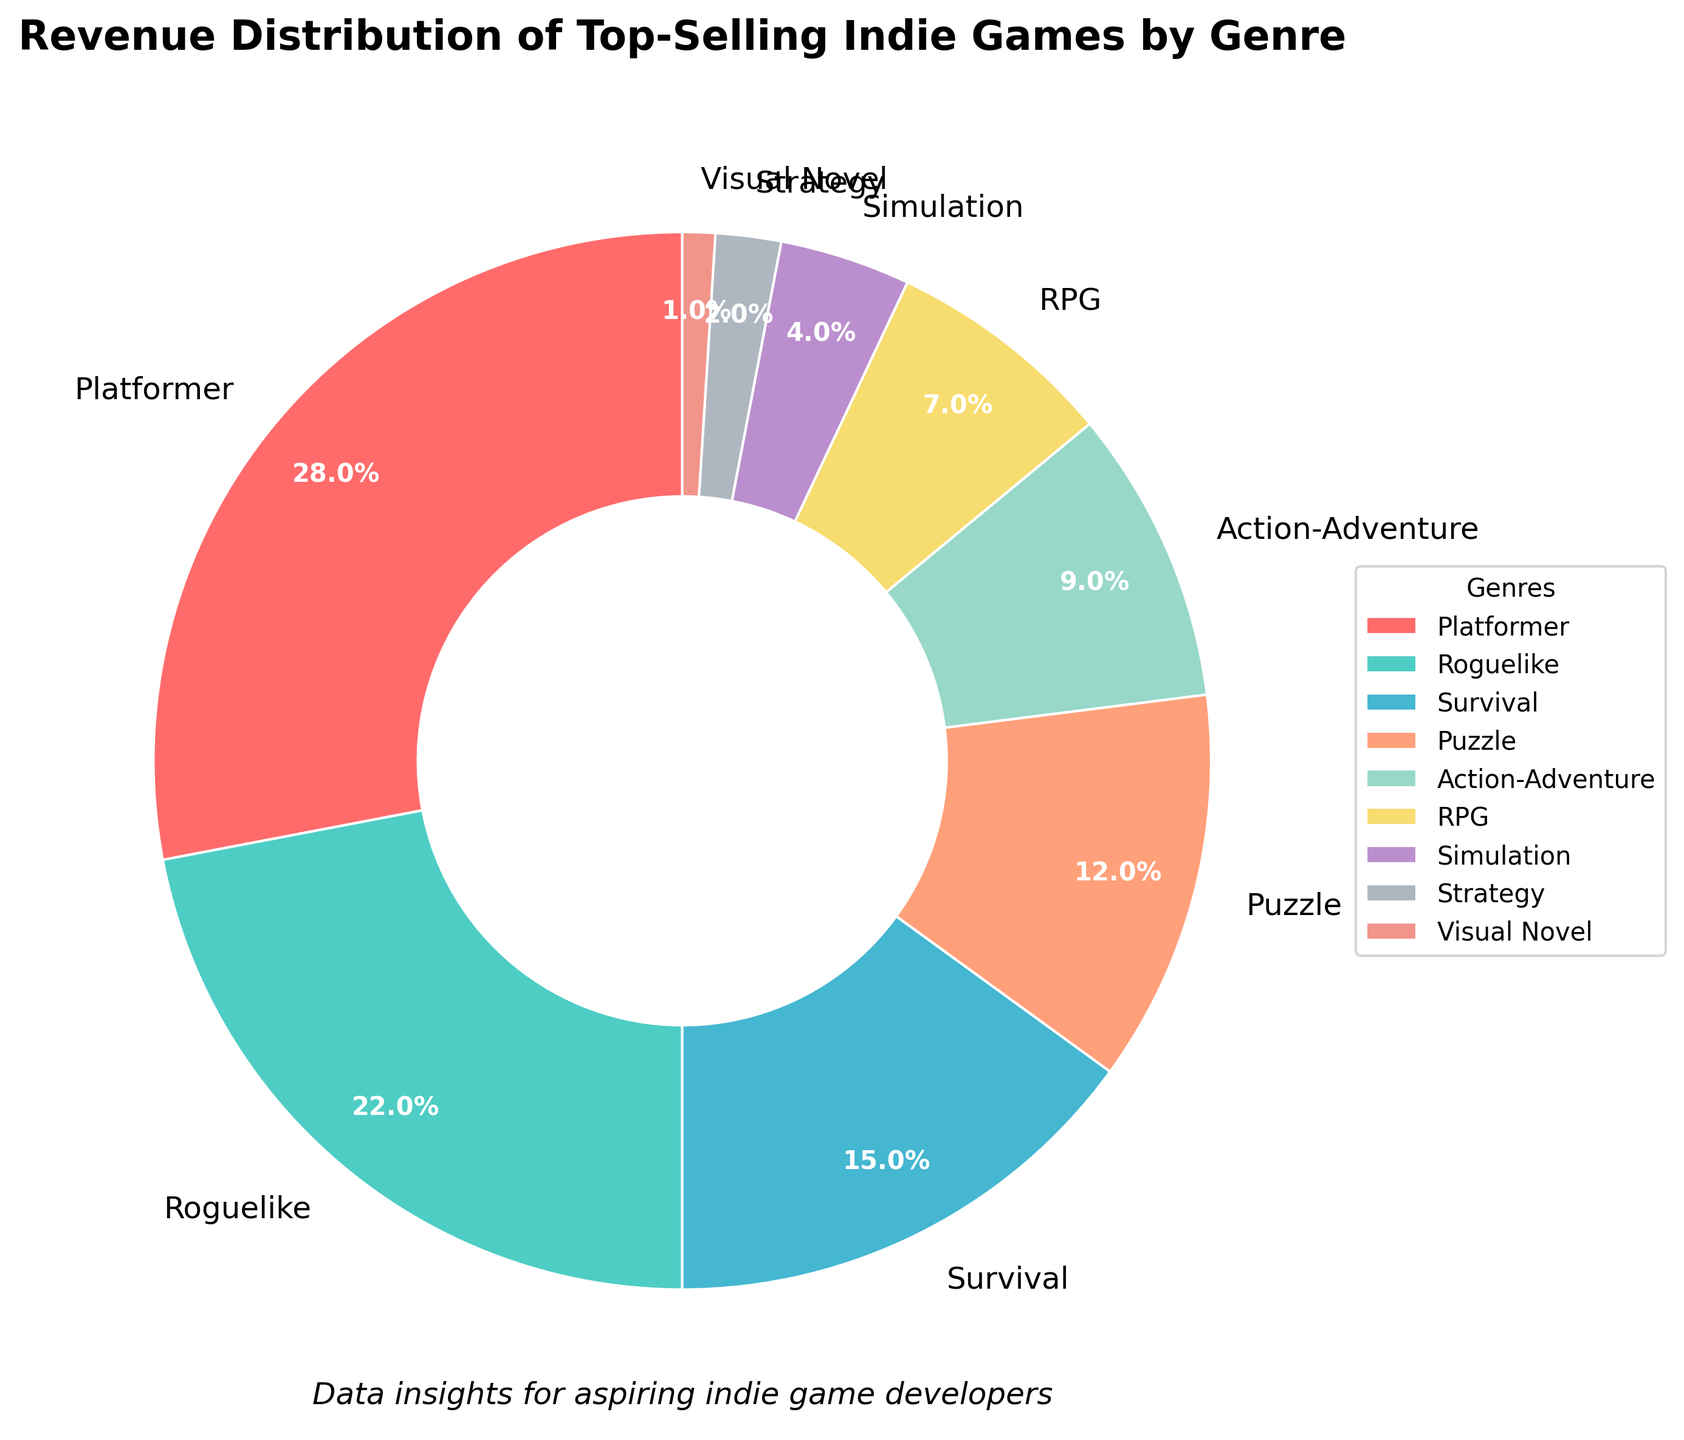Which genre contributes the highest percentage to the total revenue? The pie chart shows the revenue distribution by genre, and the largest slice represents the highest contribution. Here, "Platformer" has the biggest slice with 28%.
Answer: Platformer What is the combined revenue percentage of Roguelike and Survival genres? Sum the revenue percentages of Roguelike (22%) and Survival (15%). 22 + 15 = 37.
Answer: 37 Which genres combined contribute less than 10% each to the total revenue? Look for slices with percentages less than 10%. "Simulation," "Strategy," and "Visual Novel" have percentages of 4%, 2%, and 1%, respectively.
Answer: Simulation, Strategy, Visual Novel How much more revenue does the Platformer genre generate compared to the RPG genre? Subtract the percentage of RPG (7%) from Platformer (28%). 28 - 7 = 21.
Answer: 21 Which genre has the smallest contribution, and what is that percentage? The smallest slice shows the least contribution. "Visual Novel" has the smallest percentage at 1%.
Answer: Visual Novel, 1 What is the difference in revenue percentage between Roguelike and Action-Adventure genres? Subtract the percentage of Action-Adventure (9%) from Roguelike (22%). 22 - 9 = 13.
Answer: 13 If you combine Puzzle and RPG genres, do they surpass the revenue contribution of Survival? Add the percentages of Puzzle (12%) and RPG (7%), then compare it to Survival (15%). 12 + 7 = 19, which is greater than 15.
Answer: Yes What is the average revenue percentage of the Survival, Puzzle, and Action-Adventure genres? Sum the percentages of Survival (15%), Puzzle (12%), and Action-Adventure (9%), then divide by 3. (15 + 12 + 9) / 3 = 12.
Answer: 12 How does the revenue contribution of Simulation compare to that of Strategy? Compare the percentages directly. Simulation has 4%, and Strategy has 2%; thus, Simulation contributes more.
Answer: Simulation contributes more Which genres combined account for over 50% of the total revenue? Begin by adding the largest slices until the sum exceeds 50%. Platformer (28%) and Roguelike (22%) combine to 50%. Adding Survival (15%) exceeds 50%. So, Platformer, Roguelike, and Survival.
Answer: Platformer, Roguelike, Survival 